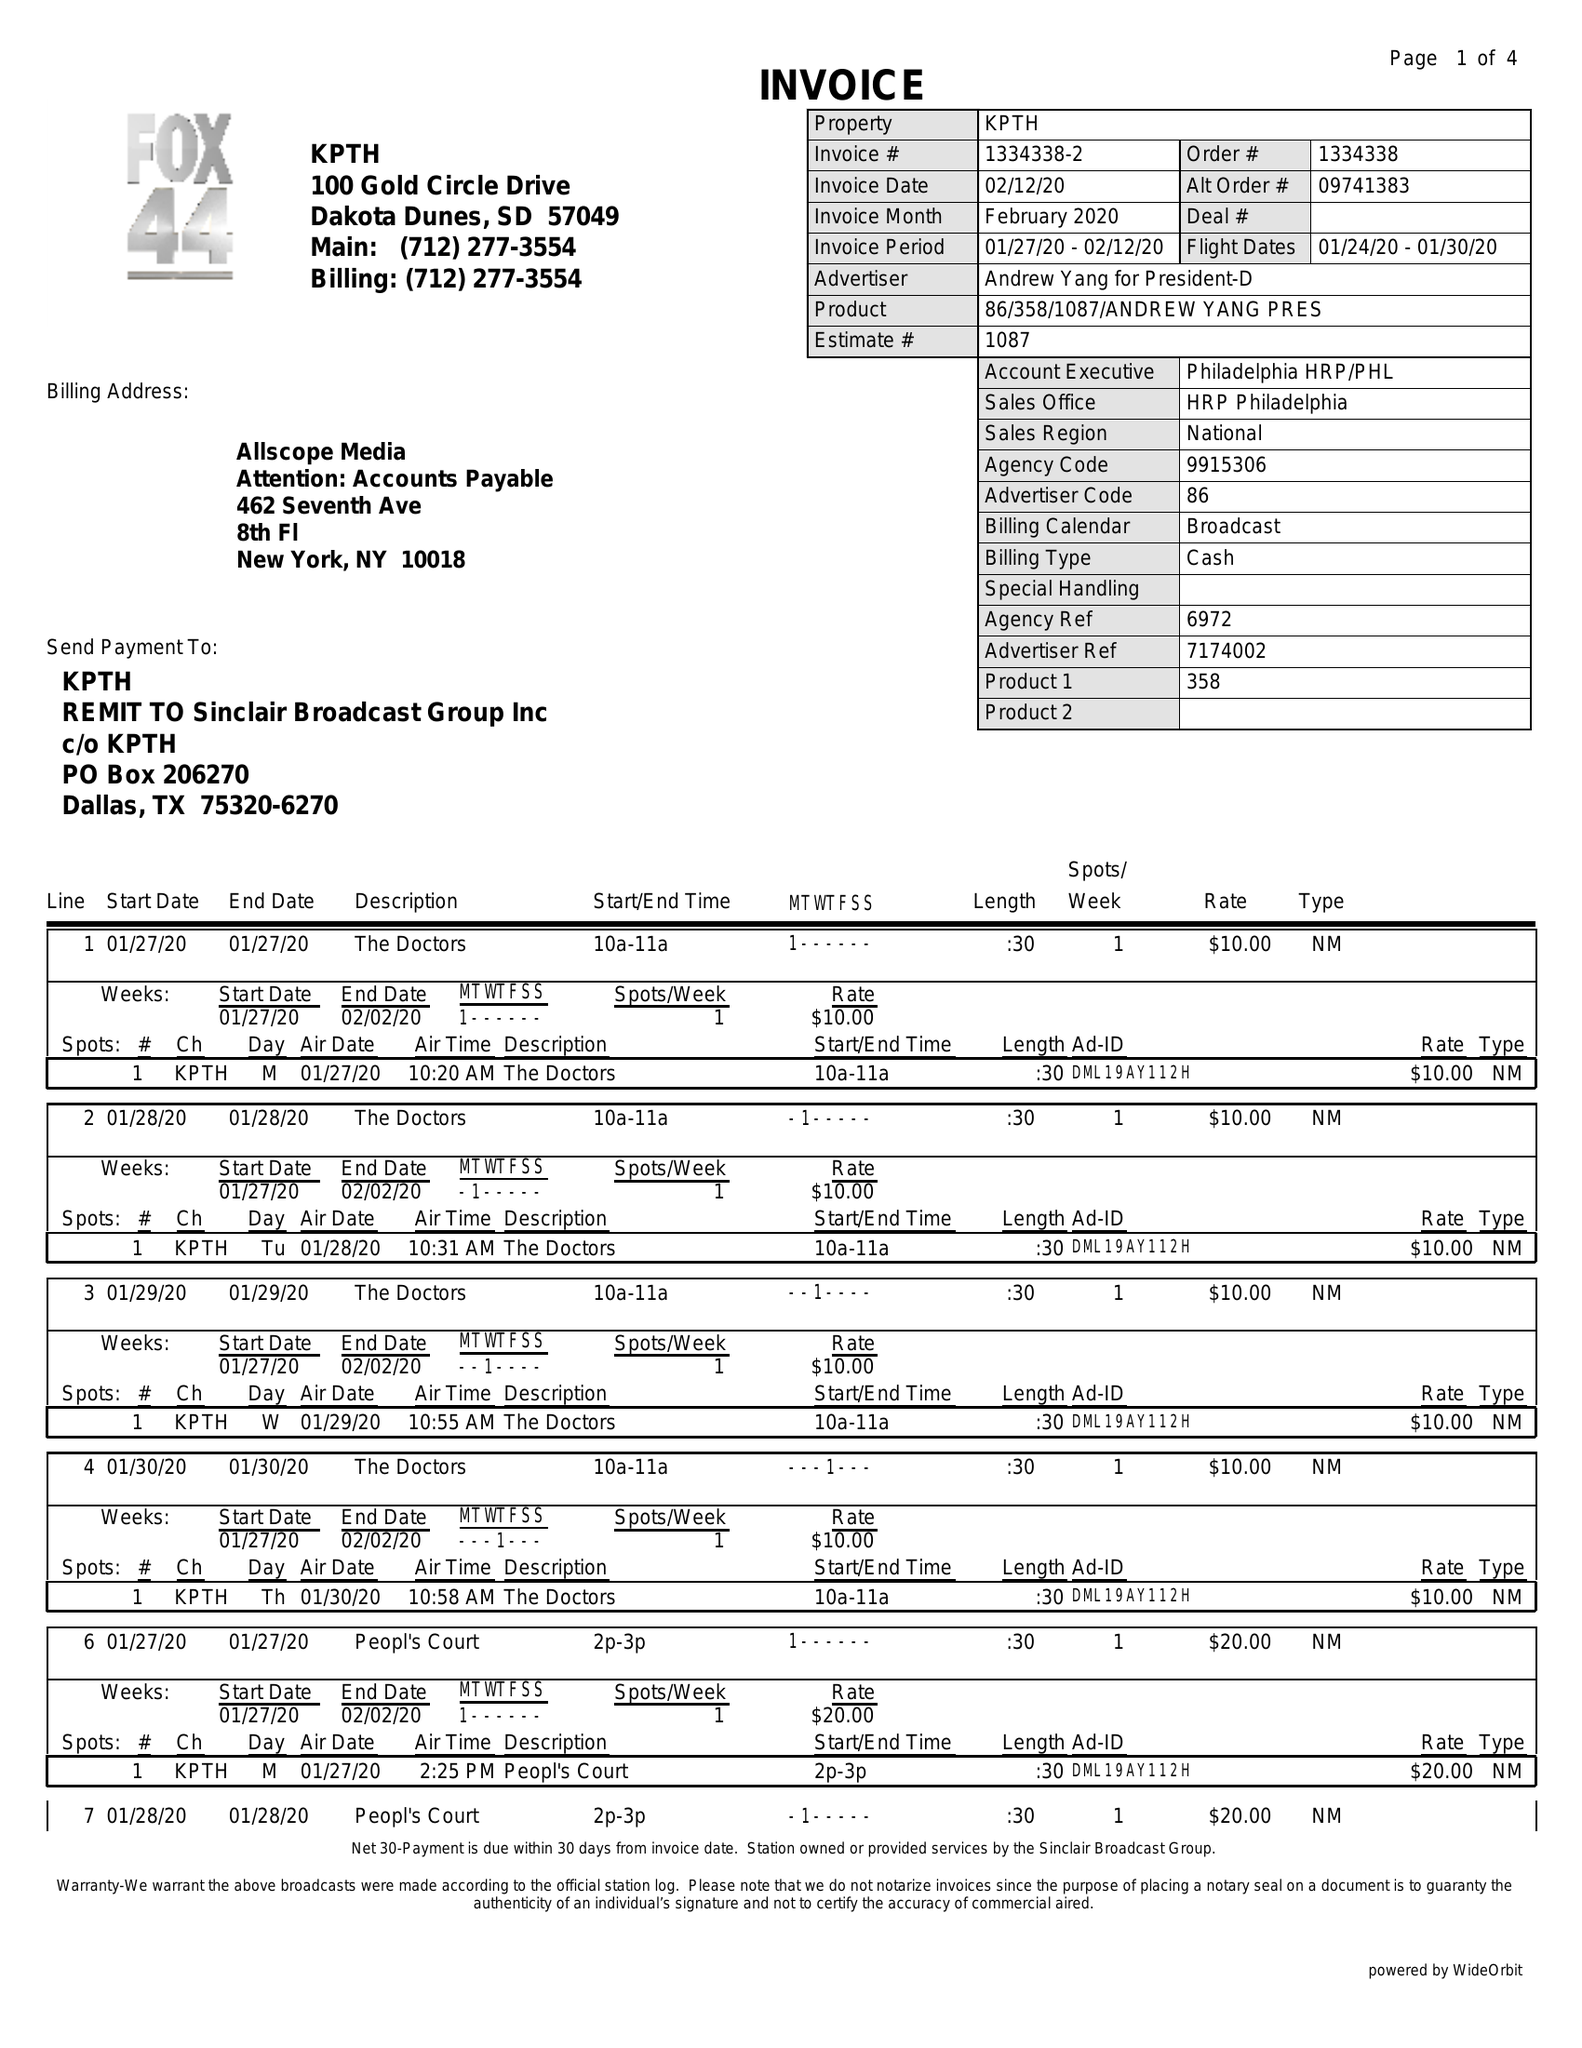What is the value for the gross_amount?
Answer the question using a single word or phrase. 1620.00 